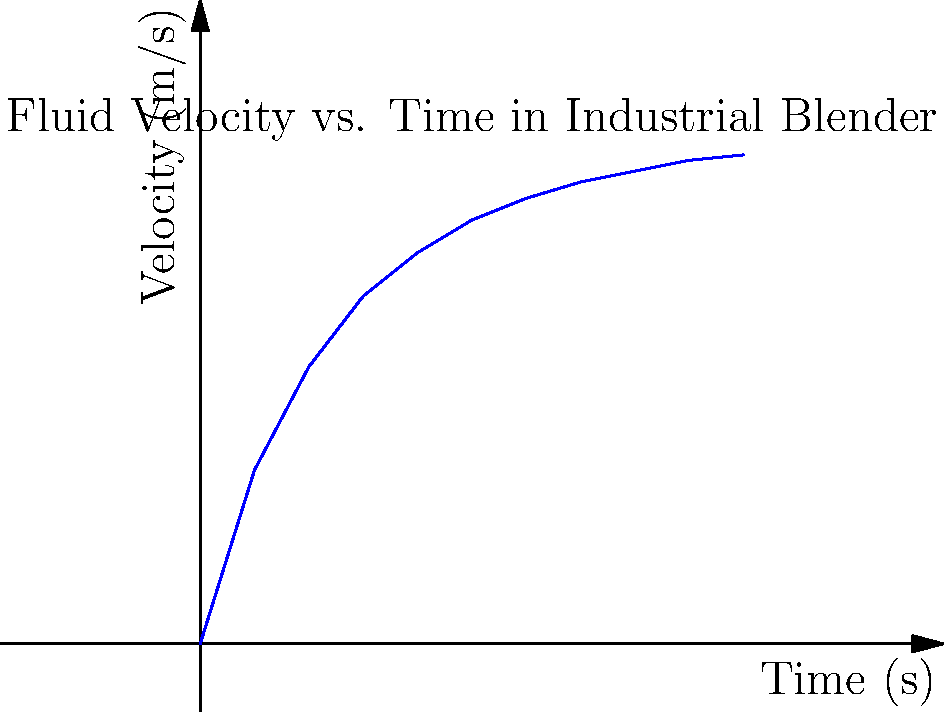In your restaurant's industrial kitchen, you're observing the mixing process of a new sauce recipe. The graph shows the velocity of fluid particles in the industrial blender over time. What physical principle best explains the shape of this curve, and how does it relate to the efficiency of mixing in your kitchen operations? To answer this question, let's analyze the graph and relate it to fluid dynamics principles:

1. Initial acceleration: The curve shows a rapid increase in velocity at the beginning, indicating the fluid is quickly accelerated by the blender's blades.

2. Decreasing rate of acceleration: The curve's slope gradually decreases, suggesting a reduction in the rate of acceleration over time.

3. Asymptotic behavior: The velocity appears to approach a maximum value, indicating a limiting factor in the system.

This behavior can be explained by the principle of drag force in fluid dynamics. As the fluid's velocity increases:

a) The drag force increases proportionally to the square of the velocity ($$F_d \propto v^2$$).
b) This increasing drag force opposes the motion imparted by the blender's blades.
c) Eventually, the drag force balances the force provided by the blades, resulting in a terminal velocity.

In terms of mixing efficiency:

1. Initial rapid acceleration ensures quick dispersion of ingredients.
2. The asymptotic behavior indicates an optimal operating speed for the blender.
3. Operating at this terminal velocity maximizes mixing efficiency while minimizing energy waste.

Understanding this principle allows for optimizing blending times and energy use in kitchen operations, potentially reducing costs and improving product consistency.
Answer: Drag force principle leading to terminal velocity 